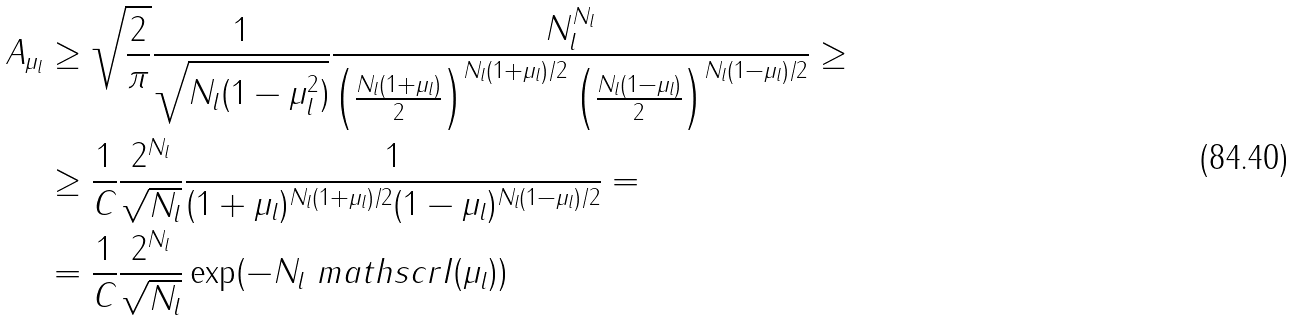Convert formula to latex. <formula><loc_0><loc_0><loc_500><loc_500>A _ { \mu _ { l } } & \geq \sqrt { \frac { 2 } { \pi } } \frac { 1 } { \sqrt { N _ { l } ( 1 - \mu _ { l } ^ { 2 } ) } } \frac { N _ { l } ^ { N _ { l } } } { \left ( \frac { N _ { l } ( 1 + \mu _ { l } ) } { 2 } \right ) ^ { N _ { l } ( 1 + \mu _ { l } ) / 2 } \left ( \frac { N _ { l } ( 1 - \mu _ { l } ) } { 2 } \right ) ^ { N _ { l } ( 1 - \mu _ { l } ) / 2 } } \geq \\ & \geq \frac { 1 } { C } \frac { 2 ^ { N _ { l } } } { \sqrt { N _ { l } } } \frac { 1 } { ( 1 + \mu _ { l } ) ^ { N _ { l } ( 1 + \mu _ { l } ) / 2 } ( 1 - \mu _ { l } ) ^ { N _ { l } ( 1 - \mu _ { l } ) / 2 } } = \\ & = \frac { 1 } { C } \frac { 2 ^ { N _ { l } } } { \sqrt { N _ { l } } } \exp ( - N _ { l } \ m a t h s c r { I } ( \mu _ { l } ) )</formula> 